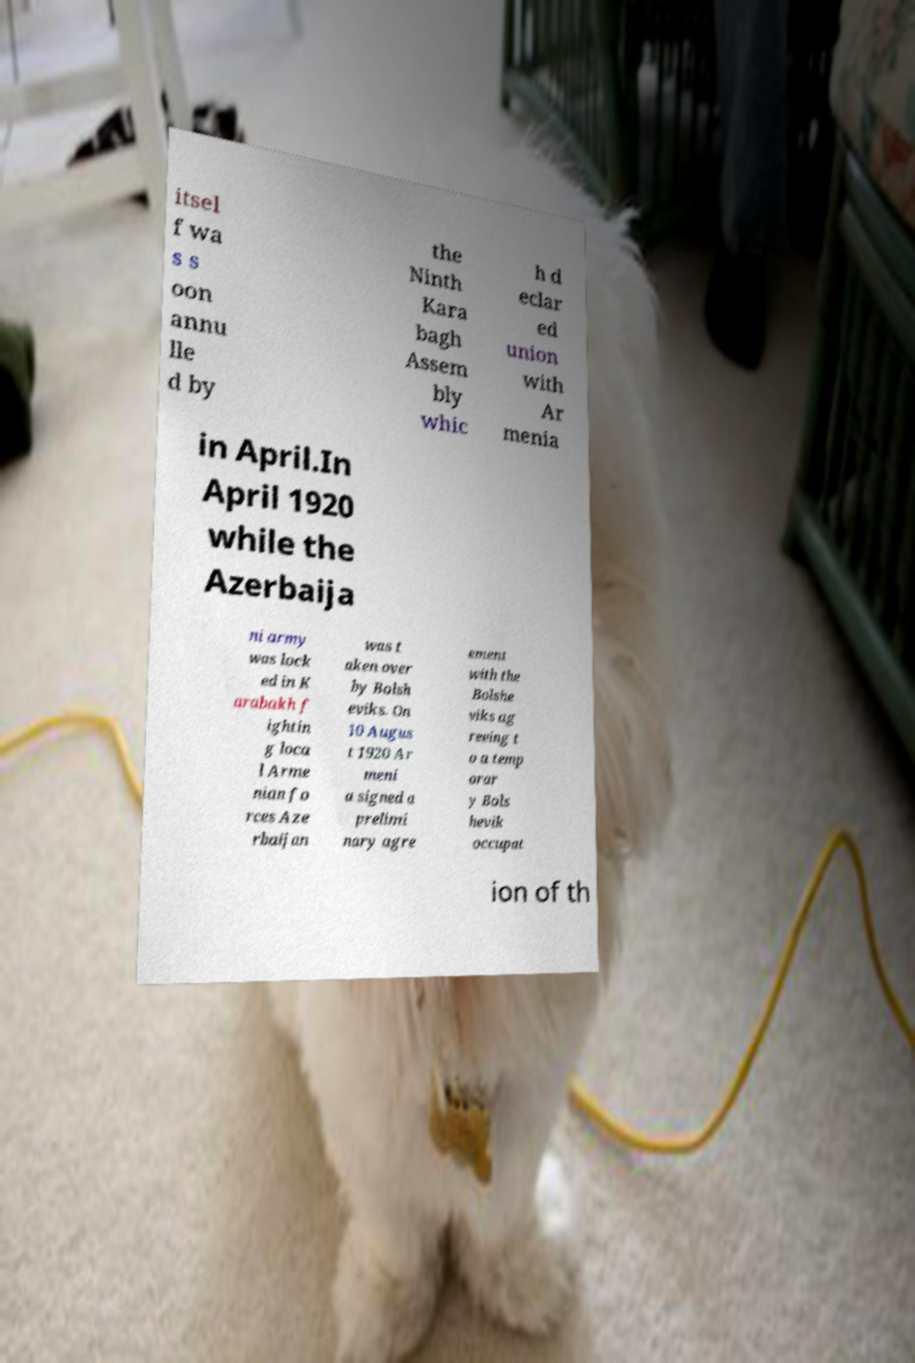Can you accurately transcribe the text from the provided image for me? itsel f wa s s oon annu lle d by the Ninth Kara bagh Assem bly whic h d eclar ed union with Ar menia in April.In April 1920 while the Azerbaija ni army was lock ed in K arabakh f ightin g loca l Arme nian fo rces Aze rbaijan was t aken over by Bolsh eviks. On 10 Augus t 1920 Ar meni a signed a prelimi nary agre ement with the Bolshe viks ag reeing t o a temp orar y Bols hevik occupat ion of th 